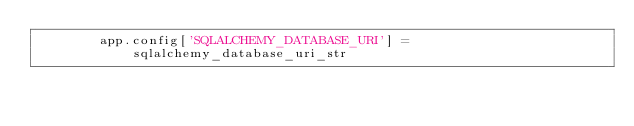Convert code to text. <code><loc_0><loc_0><loc_500><loc_500><_Python_>        app.config['SQLALCHEMY_DATABASE_URI'] = sqlalchemy_database_uri_str
</code> 